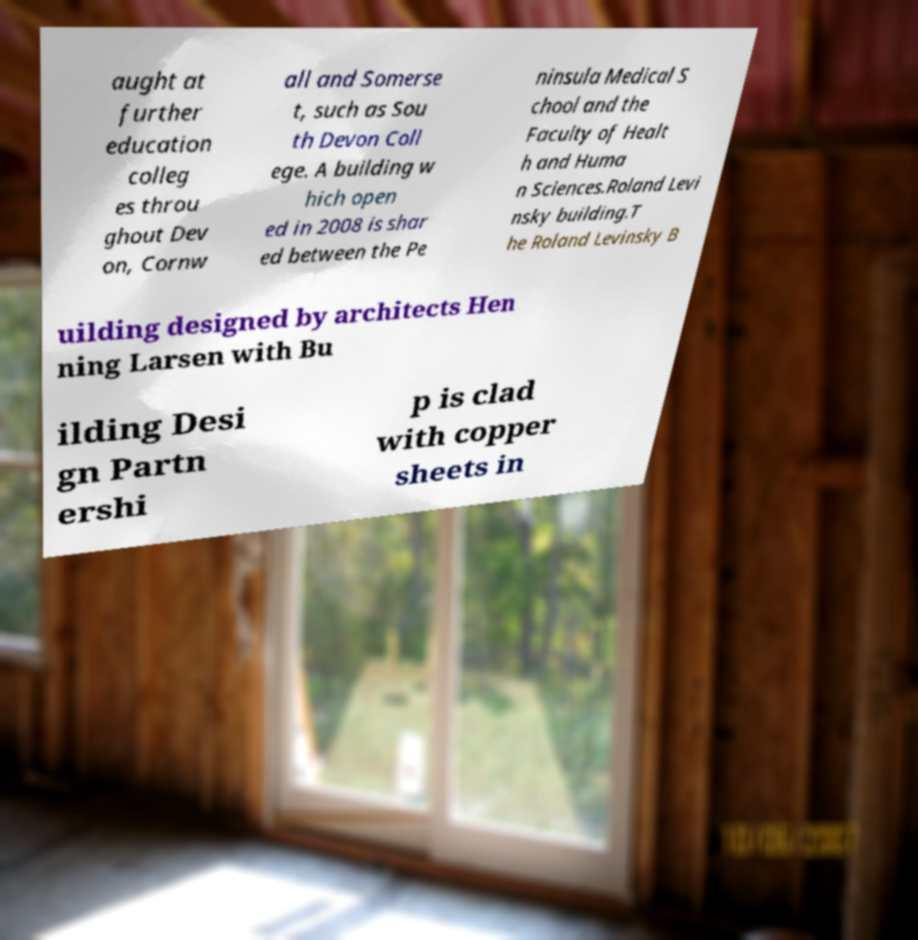There's text embedded in this image that I need extracted. Can you transcribe it verbatim? aught at further education colleg es throu ghout Dev on, Cornw all and Somerse t, such as Sou th Devon Coll ege. A building w hich open ed in 2008 is shar ed between the Pe ninsula Medical S chool and the Faculty of Healt h and Huma n Sciences.Roland Levi nsky building.T he Roland Levinsky B uilding designed by architects Hen ning Larsen with Bu ilding Desi gn Partn ershi p is clad with copper sheets in 